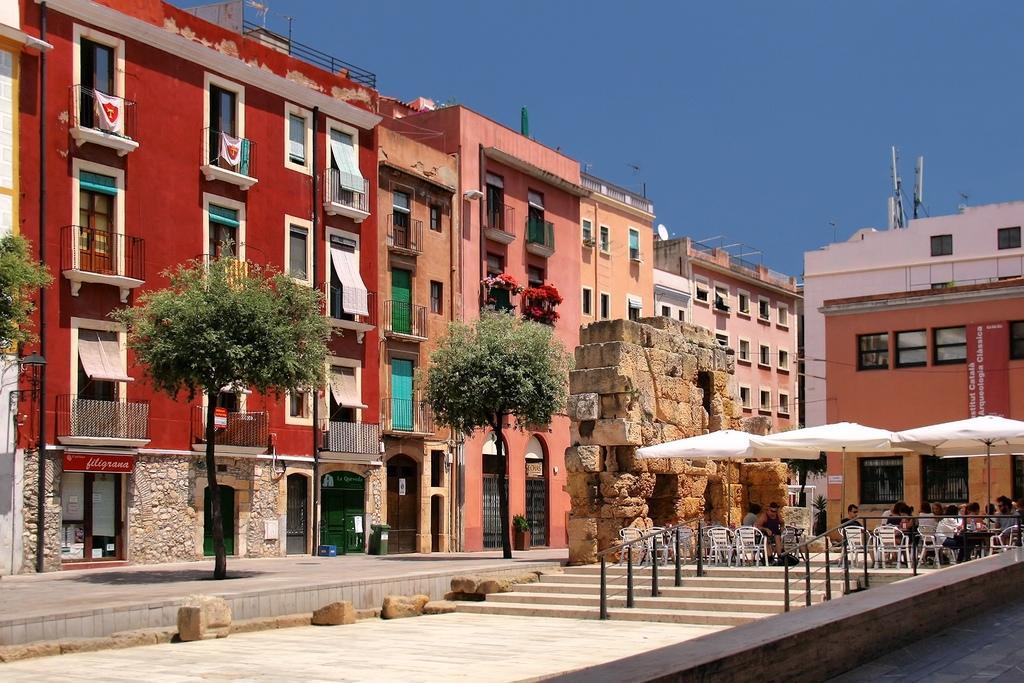Can you describe this image briefly? This is an outside. On the right side there are few people sitting on the chairs under the umbrellas and also I can see few stairs and railings. On the left side there are few buildings and trees. At the top of the image I can see the sky. At the bottom there are some stones on the ground. 